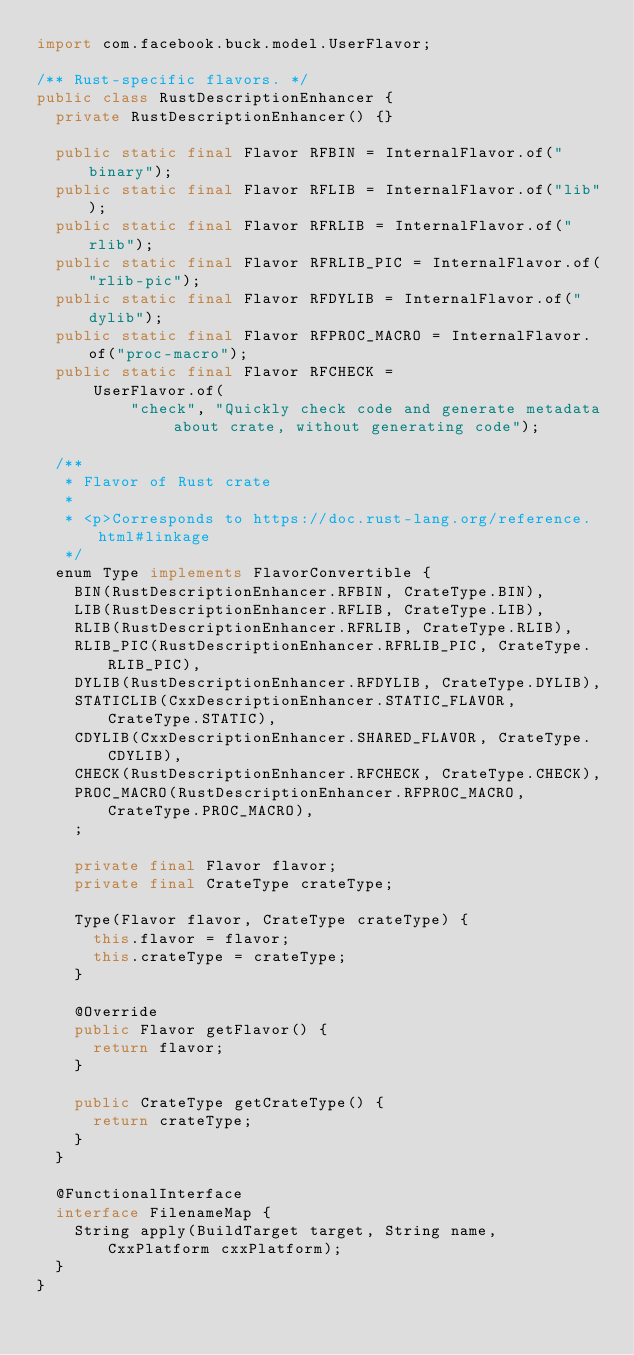<code> <loc_0><loc_0><loc_500><loc_500><_Java_>import com.facebook.buck.model.UserFlavor;

/** Rust-specific flavors. */
public class RustDescriptionEnhancer {
  private RustDescriptionEnhancer() {}

  public static final Flavor RFBIN = InternalFlavor.of("binary");
  public static final Flavor RFLIB = InternalFlavor.of("lib");
  public static final Flavor RFRLIB = InternalFlavor.of("rlib");
  public static final Flavor RFRLIB_PIC = InternalFlavor.of("rlib-pic");
  public static final Flavor RFDYLIB = InternalFlavor.of("dylib");
  public static final Flavor RFPROC_MACRO = InternalFlavor.of("proc-macro");
  public static final Flavor RFCHECK =
      UserFlavor.of(
          "check", "Quickly check code and generate metadata about crate, without generating code");

  /**
   * Flavor of Rust crate
   *
   * <p>Corresponds to https://doc.rust-lang.org/reference.html#linkage
   */
  enum Type implements FlavorConvertible {
    BIN(RustDescriptionEnhancer.RFBIN, CrateType.BIN),
    LIB(RustDescriptionEnhancer.RFLIB, CrateType.LIB),
    RLIB(RustDescriptionEnhancer.RFRLIB, CrateType.RLIB),
    RLIB_PIC(RustDescriptionEnhancer.RFRLIB_PIC, CrateType.RLIB_PIC),
    DYLIB(RustDescriptionEnhancer.RFDYLIB, CrateType.DYLIB),
    STATICLIB(CxxDescriptionEnhancer.STATIC_FLAVOR, CrateType.STATIC),
    CDYLIB(CxxDescriptionEnhancer.SHARED_FLAVOR, CrateType.CDYLIB),
    CHECK(RustDescriptionEnhancer.RFCHECK, CrateType.CHECK),
    PROC_MACRO(RustDescriptionEnhancer.RFPROC_MACRO, CrateType.PROC_MACRO),
    ;

    private final Flavor flavor;
    private final CrateType crateType;

    Type(Flavor flavor, CrateType crateType) {
      this.flavor = flavor;
      this.crateType = crateType;
    }

    @Override
    public Flavor getFlavor() {
      return flavor;
    }

    public CrateType getCrateType() {
      return crateType;
    }
  }

  @FunctionalInterface
  interface FilenameMap {
    String apply(BuildTarget target, String name, CxxPlatform cxxPlatform);
  }
}
</code> 